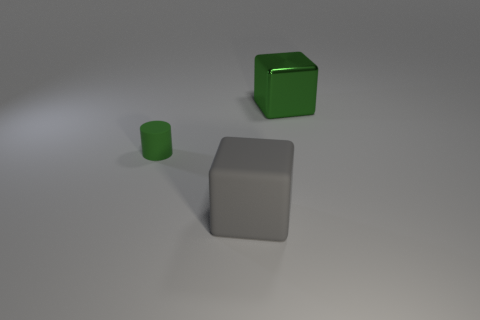What size is the object that is the same color as the matte cylinder?
Give a very brief answer. Large. What number of small things are either brown metallic blocks or gray matte cubes?
Keep it short and to the point. 0. Is the number of tiny matte cylinders left of the large green cube greater than the number of big rubber objects that are behind the large matte thing?
Ensure brevity in your answer.  Yes. Do the gray block and the green object on the left side of the green metal object have the same material?
Keep it short and to the point. Yes. What color is the large rubber block?
Offer a very short reply. Gray. What shape is the thing behind the small cylinder?
Your response must be concise. Cube. What number of green objects are either small cylinders or large matte things?
Provide a succinct answer. 1. There is a object that is made of the same material as the small cylinder; what color is it?
Ensure brevity in your answer.  Gray. There is a tiny rubber thing; does it have the same color as the big thing that is behind the cylinder?
Provide a succinct answer. Yes. There is a thing that is on the left side of the big green block and behind the large matte cube; what is its color?
Provide a succinct answer. Green. 